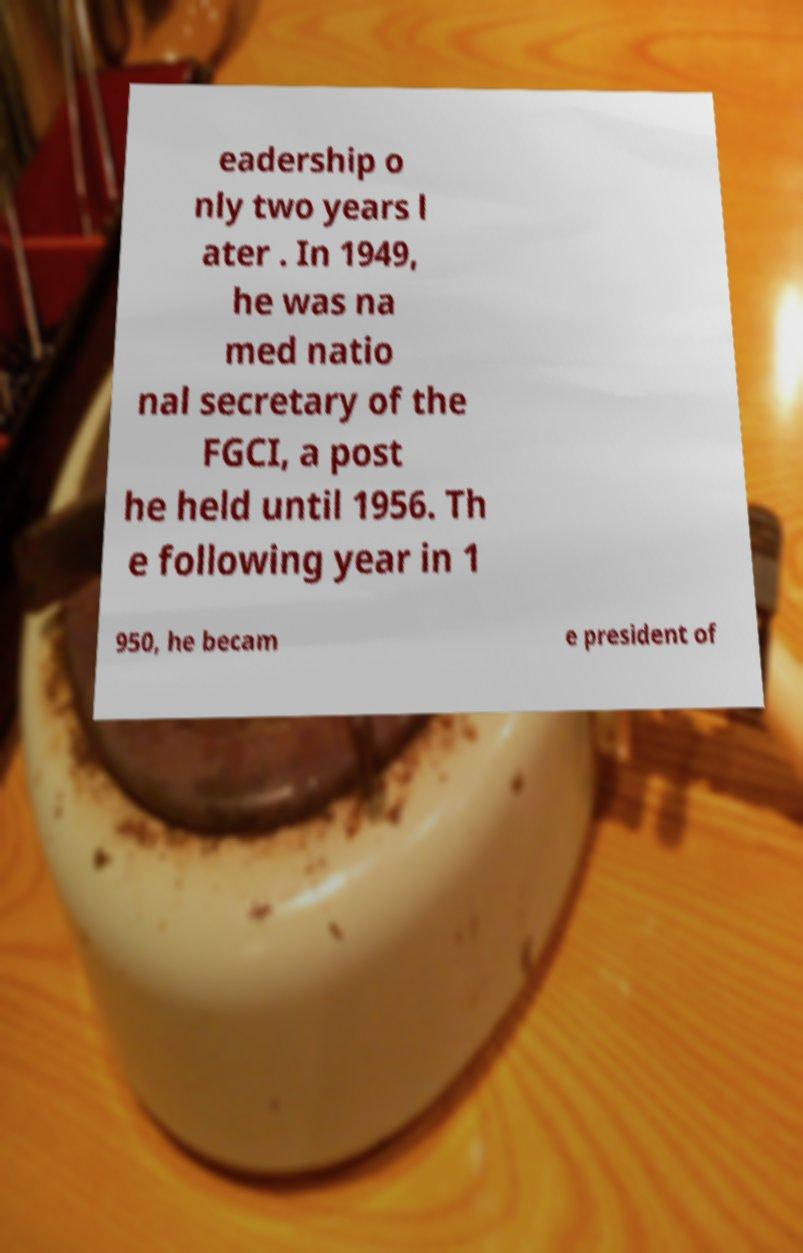For documentation purposes, I need the text within this image transcribed. Could you provide that? eadership o nly two years l ater . In 1949, he was na med natio nal secretary of the FGCI, a post he held until 1956. Th e following year in 1 950, he becam e president of 